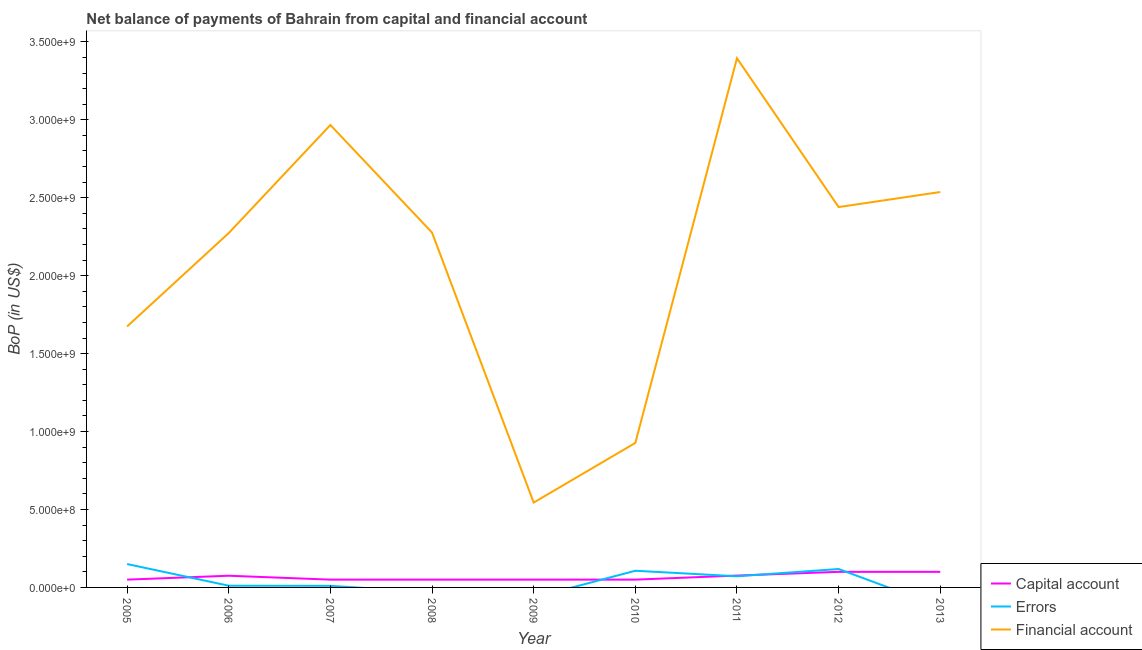What is the amount of net capital account in 2006?
Offer a terse response. 7.50e+07. Across all years, what is the maximum amount of financial account?
Your answer should be very brief. 3.39e+09. Across all years, what is the minimum amount of financial account?
Your answer should be very brief. 5.44e+08. What is the total amount of errors in the graph?
Provide a succinct answer. 4.68e+08. What is the difference between the amount of financial account in 2006 and that in 2011?
Keep it short and to the point. -1.12e+09. What is the difference between the amount of net capital account in 2010 and the amount of errors in 2007?
Provide a short and direct response. 3.98e+07. What is the average amount of net capital account per year?
Make the answer very short. 6.68e+07. In the year 2006, what is the difference between the amount of net capital account and amount of errors?
Provide a short and direct response. 6.40e+07. What is the ratio of the amount of financial account in 2006 to that in 2012?
Provide a short and direct response. 0.93. Is the amount of net capital account in 2005 less than that in 2012?
Ensure brevity in your answer.  Yes. What is the difference between the highest and the second highest amount of errors?
Offer a terse response. 3.19e+07. What is the difference between the highest and the lowest amount of errors?
Ensure brevity in your answer.  1.50e+08. Is the sum of the amount of net capital account in 2010 and 2011 greater than the maximum amount of errors across all years?
Keep it short and to the point. No. Does the amount of net capital account monotonically increase over the years?
Offer a terse response. No. Is the amount of net capital account strictly greater than the amount of errors over the years?
Keep it short and to the point. No. How many years are there in the graph?
Your response must be concise. 9. What is the difference between two consecutive major ticks on the Y-axis?
Your answer should be very brief. 5.00e+08. Are the values on the major ticks of Y-axis written in scientific E-notation?
Make the answer very short. Yes. Does the graph contain grids?
Provide a succinct answer. No. How many legend labels are there?
Give a very brief answer. 3. What is the title of the graph?
Provide a short and direct response. Net balance of payments of Bahrain from capital and financial account. What is the label or title of the Y-axis?
Ensure brevity in your answer.  BoP (in US$). What is the BoP (in US$) of Errors in 2005?
Provide a succinct answer. 1.50e+08. What is the BoP (in US$) in Financial account in 2005?
Offer a terse response. 1.67e+09. What is the BoP (in US$) in Capital account in 2006?
Keep it short and to the point. 7.50e+07. What is the BoP (in US$) in Errors in 2006?
Your answer should be compact. 1.10e+07. What is the BoP (in US$) in Financial account in 2006?
Make the answer very short. 2.27e+09. What is the BoP (in US$) in Errors in 2007?
Keep it short and to the point. 1.02e+07. What is the BoP (in US$) in Financial account in 2007?
Keep it short and to the point. 2.97e+09. What is the BoP (in US$) of Errors in 2008?
Your answer should be very brief. 0. What is the BoP (in US$) in Financial account in 2008?
Keep it short and to the point. 2.28e+09. What is the BoP (in US$) in Financial account in 2009?
Provide a short and direct response. 5.44e+08. What is the BoP (in US$) of Capital account in 2010?
Your answer should be very brief. 5.00e+07. What is the BoP (in US$) in Errors in 2010?
Give a very brief answer. 1.07e+08. What is the BoP (in US$) of Financial account in 2010?
Provide a short and direct response. 9.27e+08. What is the BoP (in US$) in Capital account in 2011?
Provide a succinct answer. 7.61e+07. What is the BoP (in US$) of Errors in 2011?
Provide a succinct answer. 7.15e+07. What is the BoP (in US$) in Financial account in 2011?
Offer a very short reply. 3.39e+09. What is the BoP (in US$) of Errors in 2012?
Provide a short and direct response. 1.18e+08. What is the BoP (in US$) in Financial account in 2012?
Make the answer very short. 2.44e+09. What is the BoP (in US$) of Capital account in 2013?
Give a very brief answer. 1.00e+08. What is the BoP (in US$) of Financial account in 2013?
Your answer should be compact. 2.54e+09. Across all years, what is the maximum BoP (in US$) of Errors?
Offer a terse response. 1.50e+08. Across all years, what is the maximum BoP (in US$) in Financial account?
Offer a terse response. 3.39e+09. Across all years, what is the minimum BoP (in US$) in Errors?
Offer a terse response. 0. Across all years, what is the minimum BoP (in US$) in Financial account?
Keep it short and to the point. 5.44e+08. What is the total BoP (in US$) in Capital account in the graph?
Your answer should be very brief. 6.01e+08. What is the total BoP (in US$) in Errors in the graph?
Ensure brevity in your answer.  4.68e+08. What is the total BoP (in US$) of Financial account in the graph?
Ensure brevity in your answer.  1.90e+1. What is the difference between the BoP (in US$) in Capital account in 2005 and that in 2006?
Make the answer very short. -2.50e+07. What is the difference between the BoP (in US$) of Errors in 2005 and that in 2006?
Provide a short and direct response. 1.39e+08. What is the difference between the BoP (in US$) of Financial account in 2005 and that in 2006?
Provide a succinct answer. -5.99e+08. What is the difference between the BoP (in US$) of Errors in 2005 and that in 2007?
Provide a succinct answer. 1.40e+08. What is the difference between the BoP (in US$) of Financial account in 2005 and that in 2007?
Offer a very short reply. -1.29e+09. What is the difference between the BoP (in US$) of Capital account in 2005 and that in 2008?
Your response must be concise. 0. What is the difference between the BoP (in US$) of Financial account in 2005 and that in 2008?
Your response must be concise. -6.02e+08. What is the difference between the BoP (in US$) of Capital account in 2005 and that in 2009?
Provide a succinct answer. 0. What is the difference between the BoP (in US$) in Financial account in 2005 and that in 2009?
Ensure brevity in your answer.  1.13e+09. What is the difference between the BoP (in US$) of Capital account in 2005 and that in 2010?
Provide a short and direct response. 0. What is the difference between the BoP (in US$) of Errors in 2005 and that in 2010?
Provide a succinct answer. 4.30e+07. What is the difference between the BoP (in US$) of Financial account in 2005 and that in 2010?
Provide a short and direct response. 7.47e+08. What is the difference between the BoP (in US$) in Capital account in 2005 and that in 2011?
Ensure brevity in your answer.  -2.61e+07. What is the difference between the BoP (in US$) in Errors in 2005 and that in 2011?
Your answer should be compact. 7.85e+07. What is the difference between the BoP (in US$) in Financial account in 2005 and that in 2011?
Make the answer very short. -1.72e+09. What is the difference between the BoP (in US$) in Capital account in 2005 and that in 2012?
Your response must be concise. -5.00e+07. What is the difference between the BoP (in US$) in Errors in 2005 and that in 2012?
Make the answer very short. 3.19e+07. What is the difference between the BoP (in US$) in Financial account in 2005 and that in 2012?
Your answer should be compact. -7.66e+08. What is the difference between the BoP (in US$) in Capital account in 2005 and that in 2013?
Offer a very short reply. -5.00e+07. What is the difference between the BoP (in US$) of Financial account in 2005 and that in 2013?
Your answer should be very brief. -8.62e+08. What is the difference between the BoP (in US$) of Capital account in 2006 and that in 2007?
Keep it short and to the point. 2.50e+07. What is the difference between the BoP (in US$) of Errors in 2006 and that in 2007?
Provide a short and direct response. 7.93e+05. What is the difference between the BoP (in US$) of Financial account in 2006 and that in 2007?
Keep it short and to the point. -6.93e+08. What is the difference between the BoP (in US$) of Capital account in 2006 and that in 2008?
Give a very brief answer. 2.50e+07. What is the difference between the BoP (in US$) of Financial account in 2006 and that in 2008?
Give a very brief answer. -3.25e+06. What is the difference between the BoP (in US$) in Capital account in 2006 and that in 2009?
Your response must be concise. 2.50e+07. What is the difference between the BoP (in US$) of Financial account in 2006 and that in 2009?
Ensure brevity in your answer.  1.73e+09. What is the difference between the BoP (in US$) in Capital account in 2006 and that in 2010?
Offer a very short reply. 2.50e+07. What is the difference between the BoP (in US$) in Errors in 2006 and that in 2010?
Ensure brevity in your answer.  -9.60e+07. What is the difference between the BoP (in US$) of Financial account in 2006 and that in 2010?
Offer a terse response. 1.35e+09. What is the difference between the BoP (in US$) in Capital account in 2006 and that in 2011?
Make the answer very short. -1.06e+06. What is the difference between the BoP (in US$) of Errors in 2006 and that in 2011?
Keep it short and to the point. -6.06e+07. What is the difference between the BoP (in US$) of Financial account in 2006 and that in 2011?
Provide a succinct answer. -1.12e+09. What is the difference between the BoP (in US$) of Capital account in 2006 and that in 2012?
Your answer should be compact. -2.50e+07. What is the difference between the BoP (in US$) in Errors in 2006 and that in 2012?
Offer a very short reply. -1.07e+08. What is the difference between the BoP (in US$) in Financial account in 2006 and that in 2012?
Offer a terse response. -1.67e+08. What is the difference between the BoP (in US$) of Capital account in 2006 and that in 2013?
Your answer should be compact. -2.50e+07. What is the difference between the BoP (in US$) in Financial account in 2006 and that in 2013?
Your answer should be compact. -2.63e+08. What is the difference between the BoP (in US$) in Financial account in 2007 and that in 2008?
Offer a very short reply. 6.90e+08. What is the difference between the BoP (in US$) in Capital account in 2007 and that in 2009?
Offer a very short reply. 0. What is the difference between the BoP (in US$) of Financial account in 2007 and that in 2009?
Give a very brief answer. 2.42e+09. What is the difference between the BoP (in US$) in Errors in 2007 and that in 2010?
Provide a succinct answer. -9.68e+07. What is the difference between the BoP (in US$) in Financial account in 2007 and that in 2010?
Your response must be concise. 2.04e+09. What is the difference between the BoP (in US$) in Capital account in 2007 and that in 2011?
Make the answer very short. -2.61e+07. What is the difference between the BoP (in US$) in Errors in 2007 and that in 2011?
Provide a short and direct response. -6.14e+07. What is the difference between the BoP (in US$) of Financial account in 2007 and that in 2011?
Ensure brevity in your answer.  -4.28e+08. What is the difference between the BoP (in US$) in Capital account in 2007 and that in 2012?
Provide a succinct answer. -5.00e+07. What is the difference between the BoP (in US$) in Errors in 2007 and that in 2012?
Give a very brief answer. -1.08e+08. What is the difference between the BoP (in US$) of Financial account in 2007 and that in 2012?
Your response must be concise. 5.27e+08. What is the difference between the BoP (in US$) of Capital account in 2007 and that in 2013?
Offer a terse response. -5.00e+07. What is the difference between the BoP (in US$) in Financial account in 2007 and that in 2013?
Provide a short and direct response. 4.30e+08. What is the difference between the BoP (in US$) of Financial account in 2008 and that in 2009?
Offer a very short reply. 1.73e+09. What is the difference between the BoP (in US$) in Financial account in 2008 and that in 2010?
Provide a short and direct response. 1.35e+09. What is the difference between the BoP (in US$) in Capital account in 2008 and that in 2011?
Offer a terse response. -2.61e+07. What is the difference between the BoP (in US$) in Financial account in 2008 and that in 2011?
Ensure brevity in your answer.  -1.12e+09. What is the difference between the BoP (in US$) in Capital account in 2008 and that in 2012?
Keep it short and to the point. -5.00e+07. What is the difference between the BoP (in US$) in Financial account in 2008 and that in 2012?
Offer a very short reply. -1.64e+08. What is the difference between the BoP (in US$) of Capital account in 2008 and that in 2013?
Your response must be concise. -5.00e+07. What is the difference between the BoP (in US$) of Financial account in 2008 and that in 2013?
Offer a very short reply. -2.60e+08. What is the difference between the BoP (in US$) in Capital account in 2009 and that in 2010?
Your response must be concise. 0. What is the difference between the BoP (in US$) of Financial account in 2009 and that in 2010?
Keep it short and to the point. -3.83e+08. What is the difference between the BoP (in US$) of Capital account in 2009 and that in 2011?
Your answer should be compact. -2.61e+07. What is the difference between the BoP (in US$) of Financial account in 2009 and that in 2011?
Provide a short and direct response. -2.85e+09. What is the difference between the BoP (in US$) of Capital account in 2009 and that in 2012?
Ensure brevity in your answer.  -5.00e+07. What is the difference between the BoP (in US$) of Financial account in 2009 and that in 2012?
Your answer should be very brief. -1.90e+09. What is the difference between the BoP (in US$) in Capital account in 2009 and that in 2013?
Keep it short and to the point. -5.00e+07. What is the difference between the BoP (in US$) of Financial account in 2009 and that in 2013?
Your response must be concise. -1.99e+09. What is the difference between the BoP (in US$) of Capital account in 2010 and that in 2011?
Make the answer very short. -2.61e+07. What is the difference between the BoP (in US$) in Errors in 2010 and that in 2011?
Give a very brief answer. 3.54e+07. What is the difference between the BoP (in US$) of Financial account in 2010 and that in 2011?
Your answer should be very brief. -2.47e+09. What is the difference between the BoP (in US$) of Capital account in 2010 and that in 2012?
Keep it short and to the point. -5.00e+07. What is the difference between the BoP (in US$) in Errors in 2010 and that in 2012?
Provide a succinct answer. -1.11e+07. What is the difference between the BoP (in US$) in Financial account in 2010 and that in 2012?
Keep it short and to the point. -1.51e+09. What is the difference between the BoP (in US$) in Capital account in 2010 and that in 2013?
Your answer should be very brief. -5.00e+07. What is the difference between the BoP (in US$) of Financial account in 2010 and that in 2013?
Give a very brief answer. -1.61e+09. What is the difference between the BoP (in US$) in Capital account in 2011 and that in 2012?
Give a very brief answer. -2.39e+07. What is the difference between the BoP (in US$) in Errors in 2011 and that in 2012?
Ensure brevity in your answer.  -4.65e+07. What is the difference between the BoP (in US$) of Financial account in 2011 and that in 2012?
Your response must be concise. 9.55e+08. What is the difference between the BoP (in US$) in Capital account in 2011 and that in 2013?
Your answer should be very brief. -2.39e+07. What is the difference between the BoP (in US$) in Financial account in 2011 and that in 2013?
Provide a short and direct response. 8.58e+08. What is the difference between the BoP (in US$) in Capital account in 2012 and that in 2013?
Make the answer very short. 0. What is the difference between the BoP (in US$) of Financial account in 2012 and that in 2013?
Make the answer very short. -9.65e+07. What is the difference between the BoP (in US$) of Capital account in 2005 and the BoP (in US$) of Errors in 2006?
Offer a terse response. 3.90e+07. What is the difference between the BoP (in US$) in Capital account in 2005 and the BoP (in US$) in Financial account in 2006?
Your answer should be very brief. -2.22e+09. What is the difference between the BoP (in US$) in Errors in 2005 and the BoP (in US$) in Financial account in 2006?
Offer a very short reply. -2.12e+09. What is the difference between the BoP (in US$) of Capital account in 2005 and the BoP (in US$) of Errors in 2007?
Your answer should be very brief. 3.98e+07. What is the difference between the BoP (in US$) in Capital account in 2005 and the BoP (in US$) in Financial account in 2007?
Offer a very short reply. -2.92e+09. What is the difference between the BoP (in US$) of Errors in 2005 and the BoP (in US$) of Financial account in 2007?
Offer a very short reply. -2.82e+09. What is the difference between the BoP (in US$) in Capital account in 2005 and the BoP (in US$) in Financial account in 2008?
Offer a very short reply. -2.23e+09. What is the difference between the BoP (in US$) of Errors in 2005 and the BoP (in US$) of Financial account in 2008?
Make the answer very short. -2.13e+09. What is the difference between the BoP (in US$) in Capital account in 2005 and the BoP (in US$) in Financial account in 2009?
Provide a short and direct response. -4.94e+08. What is the difference between the BoP (in US$) in Errors in 2005 and the BoP (in US$) in Financial account in 2009?
Ensure brevity in your answer.  -3.94e+08. What is the difference between the BoP (in US$) in Capital account in 2005 and the BoP (in US$) in Errors in 2010?
Give a very brief answer. -5.70e+07. What is the difference between the BoP (in US$) of Capital account in 2005 and the BoP (in US$) of Financial account in 2010?
Make the answer very short. -8.77e+08. What is the difference between the BoP (in US$) of Errors in 2005 and the BoP (in US$) of Financial account in 2010?
Provide a short and direct response. -7.77e+08. What is the difference between the BoP (in US$) in Capital account in 2005 and the BoP (in US$) in Errors in 2011?
Your answer should be very brief. -2.15e+07. What is the difference between the BoP (in US$) in Capital account in 2005 and the BoP (in US$) in Financial account in 2011?
Offer a terse response. -3.34e+09. What is the difference between the BoP (in US$) of Errors in 2005 and the BoP (in US$) of Financial account in 2011?
Your answer should be compact. -3.24e+09. What is the difference between the BoP (in US$) in Capital account in 2005 and the BoP (in US$) in Errors in 2012?
Give a very brief answer. -6.81e+07. What is the difference between the BoP (in US$) of Capital account in 2005 and the BoP (in US$) of Financial account in 2012?
Provide a succinct answer. -2.39e+09. What is the difference between the BoP (in US$) in Errors in 2005 and the BoP (in US$) in Financial account in 2012?
Your answer should be very brief. -2.29e+09. What is the difference between the BoP (in US$) of Capital account in 2005 and the BoP (in US$) of Financial account in 2013?
Your response must be concise. -2.49e+09. What is the difference between the BoP (in US$) of Errors in 2005 and the BoP (in US$) of Financial account in 2013?
Your answer should be very brief. -2.39e+09. What is the difference between the BoP (in US$) of Capital account in 2006 and the BoP (in US$) of Errors in 2007?
Offer a terse response. 6.48e+07. What is the difference between the BoP (in US$) in Capital account in 2006 and the BoP (in US$) in Financial account in 2007?
Ensure brevity in your answer.  -2.89e+09. What is the difference between the BoP (in US$) of Errors in 2006 and the BoP (in US$) of Financial account in 2007?
Your response must be concise. -2.96e+09. What is the difference between the BoP (in US$) of Capital account in 2006 and the BoP (in US$) of Financial account in 2008?
Your answer should be compact. -2.20e+09. What is the difference between the BoP (in US$) in Errors in 2006 and the BoP (in US$) in Financial account in 2008?
Your answer should be compact. -2.27e+09. What is the difference between the BoP (in US$) in Capital account in 2006 and the BoP (in US$) in Financial account in 2009?
Offer a very short reply. -4.69e+08. What is the difference between the BoP (in US$) of Errors in 2006 and the BoP (in US$) of Financial account in 2009?
Your answer should be very brief. -5.33e+08. What is the difference between the BoP (in US$) of Capital account in 2006 and the BoP (in US$) of Errors in 2010?
Give a very brief answer. -3.20e+07. What is the difference between the BoP (in US$) in Capital account in 2006 and the BoP (in US$) in Financial account in 2010?
Provide a succinct answer. -8.52e+08. What is the difference between the BoP (in US$) in Errors in 2006 and the BoP (in US$) in Financial account in 2010?
Your answer should be very brief. -9.16e+08. What is the difference between the BoP (in US$) of Capital account in 2006 and the BoP (in US$) of Errors in 2011?
Offer a very short reply. 3.46e+06. What is the difference between the BoP (in US$) in Capital account in 2006 and the BoP (in US$) in Financial account in 2011?
Provide a succinct answer. -3.32e+09. What is the difference between the BoP (in US$) in Errors in 2006 and the BoP (in US$) in Financial account in 2011?
Your answer should be compact. -3.38e+09. What is the difference between the BoP (in US$) in Capital account in 2006 and the BoP (in US$) in Errors in 2012?
Make the answer very short. -4.31e+07. What is the difference between the BoP (in US$) of Capital account in 2006 and the BoP (in US$) of Financial account in 2012?
Offer a terse response. -2.37e+09. What is the difference between the BoP (in US$) of Errors in 2006 and the BoP (in US$) of Financial account in 2012?
Your answer should be compact. -2.43e+09. What is the difference between the BoP (in US$) of Capital account in 2006 and the BoP (in US$) of Financial account in 2013?
Offer a very short reply. -2.46e+09. What is the difference between the BoP (in US$) of Errors in 2006 and the BoP (in US$) of Financial account in 2013?
Provide a succinct answer. -2.53e+09. What is the difference between the BoP (in US$) of Capital account in 2007 and the BoP (in US$) of Financial account in 2008?
Provide a succinct answer. -2.23e+09. What is the difference between the BoP (in US$) of Errors in 2007 and the BoP (in US$) of Financial account in 2008?
Give a very brief answer. -2.27e+09. What is the difference between the BoP (in US$) in Capital account in 2007 and the BoP (in US$) in Financial account in 2009?
Your answer should be compact. -4.94e+08. What is the difference between the BoP (in US$) of Errors in 2007 and the BoP (in US$) of Financial account in 2009?
Make the answer very short. -5.34e+08. What is the difference between the BoP (in US$) of Capital account in 2007 and the BoP (in US$) of Errors in 2010?
Make the answer very short. -5.70e+07. What is the difference between the BoP (in US$) in Capital account in 2007 and the BoP (in US$) in Financial account in 2010?
Ensure brevity in your answer.  -8.77e+08. What is the difference between the BoP (in US$) of Errors in 2007 and the BoP (in US$) of Financial account in 2010?
Make the answer very short. -9.17e+08. What is the difference between the BoP (in US$) of Capital account in 2007 and the BoP (in US$) of Errors in 2011?
Your answer should be compact. -2.15e+07. What is the difference between the BoP (in US$) of Capital account in 2007 and the BoP (in US$) of Financial account in 2011?
Give a very brief answer. -3.34e+09. What is the difference between the BoP (in US$) of Errors in 2007 and the BoP (in US$) of Financial account in 2011?
Make the answer very short. -3.38e+09. What is the difference between the BoP (in US$) in Capital account in 2007 and the BoP (in US$) in Errors in 2012?
Offer a terse response. -6.81e+07. What is the difference between the BoP (in US$) in Capital account in 2007 and the BoP (in US$) in Financial account in 2012?
Provide a short and direct response. -2.39e+09. What is the difference between the BoP (in US$) in Errors in 2007 and the BoP (in US$) in Financial account in 2012?
Offer a terse response. -2.43e+09. What is the difference between the BoP (in US$) in Capital account in 2007 and the BoP (in US$) in Financial account in 2013?
Keep it short and to the point. -2.49e+09. What is the difference between the BoP (in US$) in Errors in 2007 and the BoP (in US$) in Financial account in 2013?
Keep it short and to the point. -2.53e+09. What is the difference between the BoP (in US$) of Capital account in 2008 and the BoP (in US$) of Financial account in 2009?
Provide a short and direct response. -4.94e+08. What is the difference between the BoP (in US$) of Capital account in 2008 and the BoP (in US$) of Errors in 2010?
Keep it short and to the point. -5.70e+07. What is the difference between the BoP (in US$) in Capital account in 2008 and the BoP (in US$) in Financial account in 2010?
Ensure brevity in your answer.  -8.77e+08. What is the difference between the BoP (in US$) of Capital account in 2008 and the BoP (in US$) of Errors in 2011?
Keep it short and to the point. -2.15e+07. What is the difference between the BoP (in US$) in Capital account in 2008 and the BoP (in US$) in Financial account in 2011?
Offer a terse response. -3.34e+09. What is the difference between the BoP (in US$) of Capital account in 2008 and the BoP (in US$) of Errors in 2012?
Give a very brief answer. -6.81e+07. What is the difference between the BoP (in US$) of Capital account in 2008 and the BoP (in US$) of Financial account in 2012?
Ensure brevity in your answer.  -2.39e+09. What is the difference between the BoP (in US$) of Capital account in 2008 and the BoP (in US$) of Financial account in 2013?
Offer a very short reply. -2.49e+09. What is the difference between the BoP (in US$) in Capital account in 2009 and the BoP (in US$) in Errors in 2010?
Offer a very short reply. -5.70e+07. What is the difference between the BoP (in US$) in Capital account in 2009 and the BoP (in US$) in Financial account in 2010?
Your answer should be compact. -8.77e+08. What is the difference between the BoP (in US$) of Capital account in 2009 and the BoP (in US$) of Errors in 2011?
Your answer should be compact. -2.15e+07. What is the difference between the BoP (in US$) of Capital account in 2009 and the BoP (in US$) of Financial account in 2011?
Offer a terse response. -3.34e+09. What is the difference between the BoP (in US$) in Capital account in 2009 and the BoP (in US$) in Errors in 2012?
Keep it short and to the point. -6.81e+07. What is the difference between the BoP (in US$) of Capital account in 2009 and the BoP (in US$) of Financial account in 2012?
Offer a very short reply. -2.39e+09. What is the difference between the BoP (in US$) of Capital account in 2009 and the BoP (in US$) of Financial account in 2013?
Provide a succinct answer. -2.49e+09. What is the difference between the BoP (in US$) in Capital account in 2010 and the BoP (in US$) in Errors in 2011?
Ensure brevity in your answer.  -2.15e+07. What is the difference between the BoP (in US$) of Capital account in 2010 and the BoP (in US$) of Financial account in 2011?
Keep it short and to the point. -3.34e+09. What is the difference between the BoP (in US$) of Errors in 2010 and the BoP (in US$) of Financial account in 2011?
Make the answer very short. -3.29e+09. What is the difference between the BoP (in US$) in Capital account in 2010 and the BoP (in US$) in Errors in 2012?
Give a very brief answer. -6.81e+07. What is the difference between the BoP (in US$) of Capital account in 2010 and the BoP (in US$) of Financial account in 2012?
Your answer should be compact. -2.39e+09. What is the difference between the BoP (in US$) of Errors in 2010 and the BoP (in US$) of Financial account in 2012?
Provide a short and direct response. -2.33e+09. What is the difference between the BoP (in US$) of Capital account in 2010 and the BoP (in US$) of Financial account in 2013?
Offer a terse response. -2.49e+09. What is the difference between the BoP (in US$) of Errors in 2010 and the BoP (in US$) of Financial account in 2013?
Offer a very short reply. -2.43e+09. What is the difference between the BoP (in US$) in Capital account in 2011 and the BoP (in US$) in Errors in 2012?
Offer a terse response. -4.20e+07. What is the difference between the BoP (in US$) of Capital account in 2011 and the BoP (in US$) of Financial account in 2012?
Provide a short and direct response. -2.36e+09. What is the difference between the BoP (in US$) in Errors in 2011 and the BoP (in US$) in Financial account in 2012?
Make the answer very short. -2.37e+09. What is the difference between the BoP (in US$) in Capital account in 2011 and the BoP (in US$) in Financial account in 2013?
Your answer should be compact. -2.46e+09. What is the difference between the BoP (in US$) of Errors in 2011 and the BoP (in US$) of Financial account in 2013?
Your response must be concise. -2.47e+09. What is the difference between the BoP (in US$) in Capital account in 2012 and the BoP (in US$) in Financial account in 2013?
Your response must be concise. -2.44e+09. What is the difference between the BoP (in US$) in Errors in 2012 and the BoP (in US$) in Financial account in 2013?
Provide a short and direct response. -2.42e+09. What is the average BoP (in US$) in Capital account per year?
Ensure brevity in your answer.  6.68e+07. What is the average BoP (in US$) in Errors per year?
Ensure brevity in your answer.  5.20e+07. What is the average BoP (in US$) in Financial account per year?
Your answer should be very brief. 2.11e+09. In the year 2005, what is the difference between the BoP (in US$) of Capital account and BoP (in US$) of Errors?
Make the answer very short. -1.00e+08. In the year 2005, what is the difference between the BoP (in US$) of Capital account and BoP (in US$) of Financial account?
Your answer should be compact. -1.62e+09. In the year 2005, what is the difference between the BoP (in US$) of Errors and BoP (in US$) of Financial account?
Offer a terse response. -1.52e+09. In the year 2006, what is the difference between the BoP (in US$) in Capital account and BoP (in US$) in Errors?
Your response must be concise. 6.40e+07. In the year 2006, what is the difference between the BoP (in US$) in Capital account and BoP (in US$) in Financial account?
Your response must be concise. -2.20e+09. In the year 2006, what is the difference between the BoP (in US$) of Errors and BoP (in US$) of Financial account?
Provide a succinct answer. -2.26e+09. In the year 2007, what is the difference between the BoP (in US$) in Capital account and BoP (in US$) in Errors?
Your answer should be compact. 3.98e+07. In the year 2007, what is the difference between the BoP (in US$) in Capital account and BoP (in US$) in Financial account?
Keep it short and to the point. -2.92e+09. In the year 2007, what is the difference between the BoP (in US$) of Errors and BoP (in US$) of Financial account?
Provide a short and direct response. -2.96e+09. In the year 2008, what is the difference between the BoP (in US$) in Capital account and BoP (in US$) in Financial account?
Provide a short and direct response. -2.23e+09. In the year 2009, what is the difference between the BoP (in US$) in Capital account and BoP (in US$) in Financial account?
Make the answer very short. -4.94e+08. In the year 2010, what is the difference between the BoP (in US$) in Capital account and BoP (in US$) in Errors?
Your answer should be very brief. -5.70e+07. In the year 2010, what is the difference between the BoP (in US$) of Capital account and BoP (in US$) of Financial account?
Offer a terse response. -8.77e+08. In the year 2010, what is the difference between the BoP (in US$) of Errors and BoP (in US$) of Financial account?
Provide a succinct answer. -8.20e+08. In the year 2011, what is the difference between the BoP (in US$) of Capital account and BoP (in US$) of Errors?
Your response must be concise. 4.52e+06. In the year 2011, what is the difference between the BoP (in US$) in Capital account and BoP (in US$) in Financial account?
Provide a succinct answer. -3.32e+09. In the year 2011, what is the difference between the BoP (in US$) in Errors and BoP (in US$) in Financial account?
Provide a short and direct response. -3.32e+09. In the year 2012, what is the difference between the BoP (in US$) in Capital account and BoP (in US$) in Errors?
Your answer should be very brief. -1.81e+07. In the year 2012, what is the difference between the BoP (in US$) in Capital account and BoP (in US$) in Financial account?
Provide a short and direct response. -2.34e+09. In the year 2012, what is the difference between the BoP (in US$) in Errors and BoP (in US$) in Financial account?
Your answer should be very brief. -2.32e+09. In the year 2013, what is the difference between the BoP (in US$) of Capital account and BoP (in US$) of Financial account?
Offer a terse response. -2.44e+09. What is the ratio of the BoP (in US$) in Errors in 2005 to that in 2006?
Keep it short and to the point. 13.69. What is the ratio of the BoP (in US$) in Financial account in 2005 to that in 2006?
Offer a very short reply. 0.74. What is the ratio of the BoP (in US$) in Errors in 2005 to that in 2007?
Make the answer very short. 14.76. What is the ratio of the BoP (in US$) of Financial account in 2005 to that in 2007?
Your answer should be very brief. 0.56. What is the ratio of the BoP (in US$) in Capital account in 2005 to that in 2008?
Your response must be concise. 1. What is the ratio of the BoP (in US$) in Financial account in 2005 to that in 2008?
Keep it short and to the point. 0.74. What is the ratio of the BoP (in US$) of Capital account in 2005 to that in 2009?
Your answer should be very brief. 1. What is the ratio of the BoP (in US$) of Financial account in 2005 to that in 2009?
Offer a very short reply. 3.08. What is the ratio of the BoP (in US$) in Capital account in 2005 to that in 2010?
Ensure brevity in your answer.  1. What is the ratio of the BoP (in US$) of Errors in 2005 to that in 2010?
Your response must be concise. 1.4. What is the ratio of the BoP (in US$) of Financial account in 2005 to that in 2010?
Your answer should be very brief. 1.81. What is the ratio of the BoP (in US$) of Capital account in 2005 to that in 2011?
Provide a succinct answer. 0.66. What is the ratio of the BoP (in US$) in Errors in 2005 to that in 2011?
Offer a very short reply. 2.1. What is the ratio of the BoP (in US$) of Financial account in 2005 to that in 2011?
Provide a short and direct response. 0.49. What is the ratio of the BoP (in US$) in Errors in 2005 to that in 2012?
Ensure brevity in your answer.  1.27. What is the ratio of the BoP (in US$) of Financial account in 2005 to that in 2012?
Your answer should be very brief. 0.69. What is the ratio of the BoP (in US$) in Capital account in 2005 to that in 2013?
Offer a very short reply. 0.5. What is the ratio of the BoP (in US$) of Financial account in 2005 to that in 2013?
Offer a very short reply. 0.66. What is the ratio of the BoP (in US$) of Errors in 2006 to that in 2007?
Provide a short and direct response. 1.08. What is the ratio of the BoP (in US$) in Financial account in 2006 to that in 2007?
Make the answer very short. 0.77. What is the ratio of the BoP (in US$) of Capital account in 2006 to that in 2009?
Keep it short and to the point. 1.5. What is the ratio of the BoP (in US$) in Financial account in 2006 to that in 2009?
Provide a succinct answer. 4.18. What is the ratio of the BoP (in US$) of Errors in 2006 to that in 2010?
Ensure brevity in your answer.  0.1. What is the ratio of the BoP (in US$) of Financial account in 2006 to that in 2010?
Keep it short and to the point. 2.45. What is the ratio of the BoP (in US$) of Errors in 2006 to that in 2011?
Provide a succinct answer. 0.15. What is the ratio of the BoP (in US$) of Financial account in 2006 to that in 2011?
Your response must be concise. 0.67. What is the ratio of the BoP (in US$) of Errors in 2006 to that in 2012?
Make the answer very short. 0.09. What is the ratio of the BoP (in US$) in Financial account in 2006 to that in 2012?
Offer a very short reply. 0.93. What is the ratio of the BoP (in US$) in Capital account in 2006 to that in 2013?
Ensure brevity in your answer.  0.75. What is the ratio of the BoP (in US$) of Financial account in 2006 to that in 2013?
Your answer should be very brief. 0.9. What is the ratio of the BoP (in US$) of Capital account in 2007 to that in 2008?
Your answer should be very brief. 1. What is the ratio of the BoP (in US$) in Financial account in 2007 to that in 2008?
Offer a very short reply. 1.3. What is the ratio of the BoP (in US$) in Capital account in 2007 to that in 2009?
Your answer should be compact. 1. What is the ratio of the BoP (in US$) of Financial account in 2007 to that in 2009?
Provide a succinct answer. 5.45. What is the ratio of the BoP (in US$) of Errors in 2007 to that in 2010?
Your response must be concise. 0.1. What is the ratio of the BoP (in US$) of Financial account in 2007 to that in 2010?
Your answer should be very brief. 3.2. What is the ratio of the BoP (in US$) of Capital account in 2007 to that in 2011?
Keep it short and to the point. 0.66. What is the ratio of the BoP (in US$) of Errors in 2007 to that in 2011?
Offer a very short reply. 0.14. What is the ratio of the BoP (in US$) in Financial account in 2007 to that in 2011?
Make the answer very short. 0.87. What is the ratio of the BoP (in US$) in Capital account in 2007 to that in 2012?
Make the answer very short. 0.5. What is the ratio of the BoP (in US$) in Errors in 2007 to that in 2012?
Offer a terse response. 0.09. What is the ratio of the BoP (in US$) of Financial account in 2007 to that in 2012?
Your answer should be compact. 1.22. What is the ratio of the BoP (in US$) in Financial account in 2007 to that in 2013?
Ensure brevity in your answer.  1.17. What is the ratio of the BoP (in US$) in Capital account in 2008 to that in 2009?
Offer a very short reply. 1. What is the ratio of the BoP (in US$) of Financial account in 2008 to that in 2009?
Provide a short and direct response. 4.18. What is the ratio of the BoP (in US$) in Financial account in 2008 to that in 2010?
Offer a very short reply. 2.46. What is the ratio of the BoP (in US$) in Capital account in 2008 to that in 2011?
Make the answer very short. 0.66. What is the ratio of the BoP (in US$) in Financial account in 2008 to that in 2011?
Provide a short and direct response. 0.67. What is the ratio of the BoP (in US$) of Capital account in 2008 to that in 2012?
Your answer should be very brief. 0.5. What is the ratio of the BoP (in US$) of Financial account in 2008 to that in 2012?
Your response must be concise. 0.93. What is the ratio of the BoP (in US$) in Financial account in 2008 to that in 2013?
Make the answer very short. 0.9. What is the ratio of the BoP (in US$) in Financial account in 2009 to that in 2010?
Your answer should be compact. 0.59. What is the ratio of the BoP (in US$) of Capital account in 2009 to that in 2011?
Provide a succinct answer. 0.66. What is the ratio of the BoP (in US$) of Financial account in 2009 to that in 2011?
Offer a very short reply. 0.16. What is the ratio of the BoP (in US$) of Financial account in 2009 to that in 2012?
Give a very brief answer. 0.22. What is the ratio of the BoP (in US$) of Financial account in 2009 to that in 2013?
Provide a short and direct response. 0.21. What is the ratio of the BoP (in US$) in Capital account in 2010 to that in 2011?
Offer a very short reply. 0.66. What is the ratio of the BoP (in US$) in Errors in 2010 to that in 2011?
Make the answer very short. 1.5. What is the ratio of the BoP (in US$) in Financial account in 2010 to that in 2011?
Ensure brevity in your answer.  0.27. What is the ratio of the BoP (in US$) in Capital account in 2010 to that in 2012?
Provide a succinct answer. 0.5. What is the ratio of the BoP (in US$) in Errors in 2010 to that in 2012?
Offer a very short reply. 0.91. What is the ratio of the BoP (in US$) of Financial account in 2010 to that in 2012?
Offer a very short reply. 0.38. What is the ratio of the BoP (in US$) in Financial account in 2010 to that in 2013?
Your answer should be very brief. 0.37. What is the ratio of the BoP (in US$) of Capital account in 2011 to that in 2012?
Offer a very short reply. 0.76. What is the ratio of the BoP (in US$) of Errors in 2011 to that in 2012?
Provide a short and direct response. 0.61. What is the ratio of the BoP (in US$) of Financial account in 2011 to that in 2012?
Your answer should be very brief. 1.39. What is the ratio of the BoP (in US$) in Capital account in 2011 to that in 2013?
Make the answer very short. 0.76. What is the ratio of the BoP (in US$) in Financial account in 2011 to that in 2013?
Give a very brief answer. 1.34. What is the ratio of the BoP (in US$) of Capital account in 2012 to that in 2013?
Your response must be concise. 1. What is the ratio of the BoP (in US$) of Financial account in 2012 to that in 2013?
Offer a terse response. 0.96. What is the difference between the highest and the second highest BoP (in US$) of Errors?
Make the answer very short. 3.19e+07. What is the difference between the highest and the second highest BoP (in US$) in Financial account?
Your response must be concise. 4.28e+08. What is the difference between the highest and the lowest BoP (in US$) in Errors?
Your answer should be compact. 1.50e+08. What is the difference between the highest and the lowest BoP (in US$) of Financial account?
Ensure brevity in your answer.  2.85e+09. 